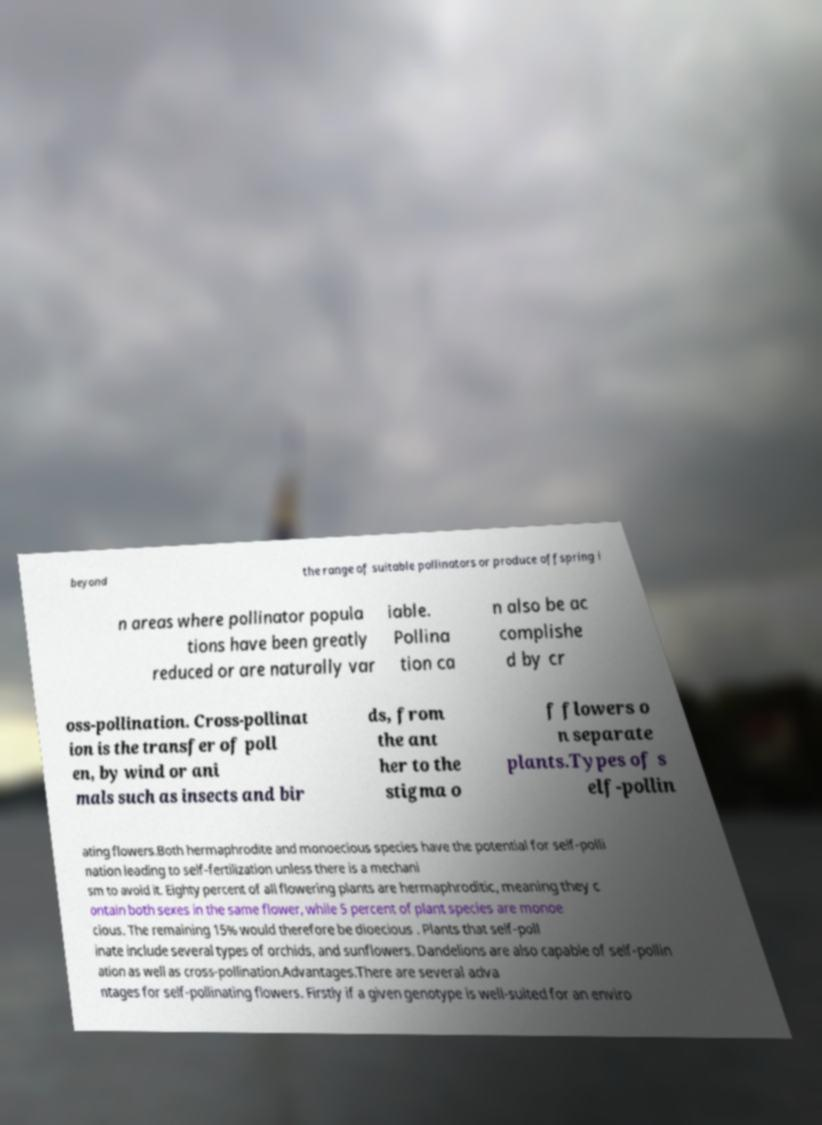Could you extract and type out the text from this image? beyond the range of suitable pollinators or produce offspring i n areas where pollinator popula tions have been greatly reduced or are naturally var iable. Pollina tion ca n also be ac complishe d by cr oss-pollination. Cross-pollinat ion is the transfer of poll en, by wind or ani mals such as insects and bir ds, from the ant her to the stigma o f flowers o n separate plants.Types of s elf-pollin ating flowers.Both hermaphrodite and monoecious species have the potential for self-polli nation leading to self-fertilization unless there is a mechani sm to avoid it. Eighty percent of all flowering plants are hermaphroditic, meaning they c ontain both sexes in the same flower, while 5 percent of plant species are monoe cious. The remaining 15% would therefore be dioecious . Plants that self-poll inate include several types of orchids, and sunflowers. Dandelions are also capable of self-pollin ation as well as cross-pollination.Advantages.There are several adva ntages for self-pollinating flowers. Firstly if a given genotype is well-suited for an enviro 